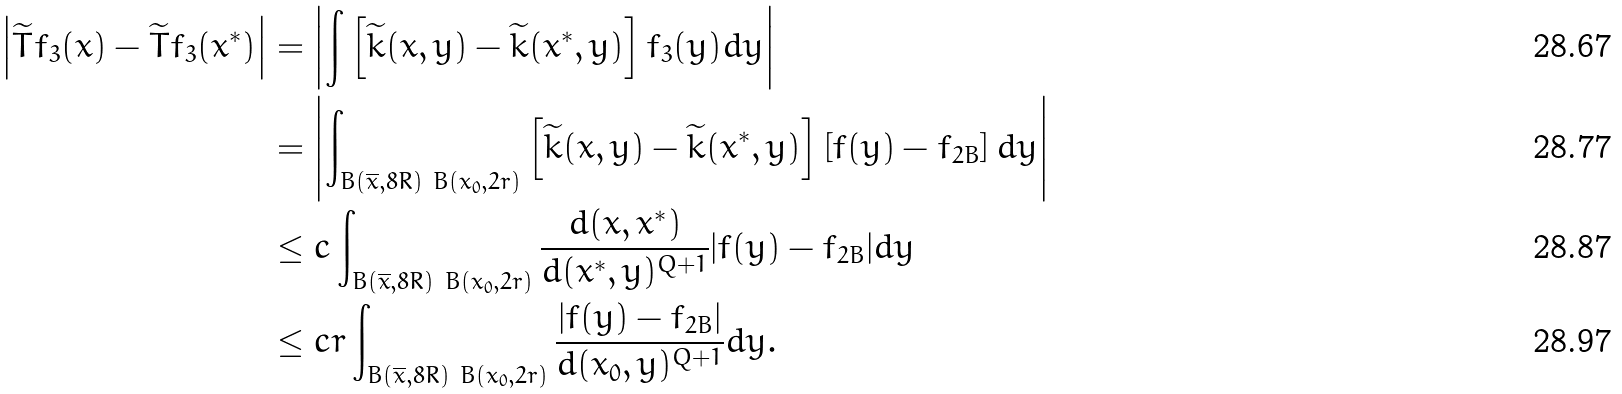<formula> <loc_0><loc_0><loc_500><loc_500>\left | \widetilde { T } f _ { 3 } ( x ) - \widetilde { T } f _ { 3 } ( x ^ { \ast } ) \right | & = \left | \int \left [ \widetilde { k } ( x , y ) - \widetilde { k } ( x ^ { \ast } , y ) \right ] f _ { 3 } ( y ) d y \right | \\ & = \left | \int _ { B \left ( \overline { x } , 8 R \right ) \ B \left ( x _ { 0 } , 2 r \right ) } \left [ \widetilde { k } ( x , y ) - \widetilde { k } ( x ^ { \ast } , y ) \right ] \left [ f ( y ) - f _ { 2 B } \right ] d y \right | \\ & \leq c \int _ { B \left ( \overline { x } , 8 R \right ) \ B \left ( x _ { 0 } , 2 r \right ) } \frac { d ( x , x ^ { \ast } ) } { d ( x ^ { \ast } , y ) ^ { Q + 1 } } | f ( y ) - f _ { 2 B } | d y \\ & \leq c r \int _ { B \left ( \overline { x } , 8 R \right ) \ B \left ( x _ { 0 } , 2 r \right ) } \frac { | f ( y ) - f _ { 2 B } | } { d ( x _ { 0 } , y ) ^ { Q + 1 } } d y .</formula> 